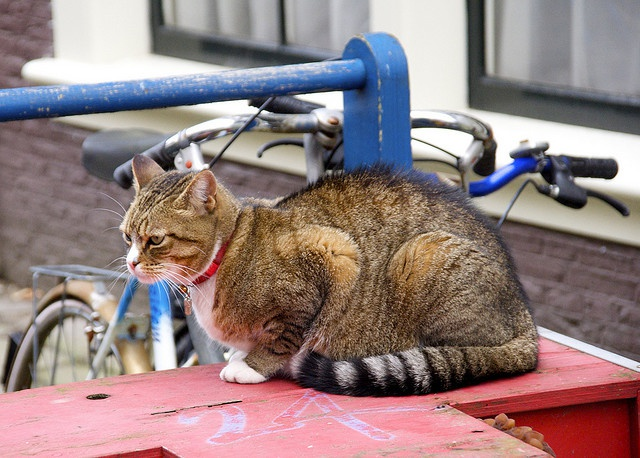Describe the objects in this image and their specific colors. I can see cat in gray, maroon, and black tones, bicycle in gray, darkgray, black, and lightgray tones, and bicycle in gray, darkgray, and black tones in this image. 